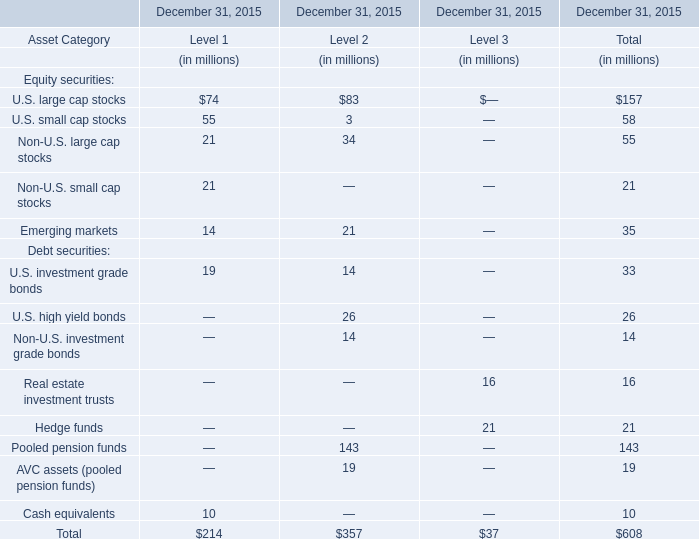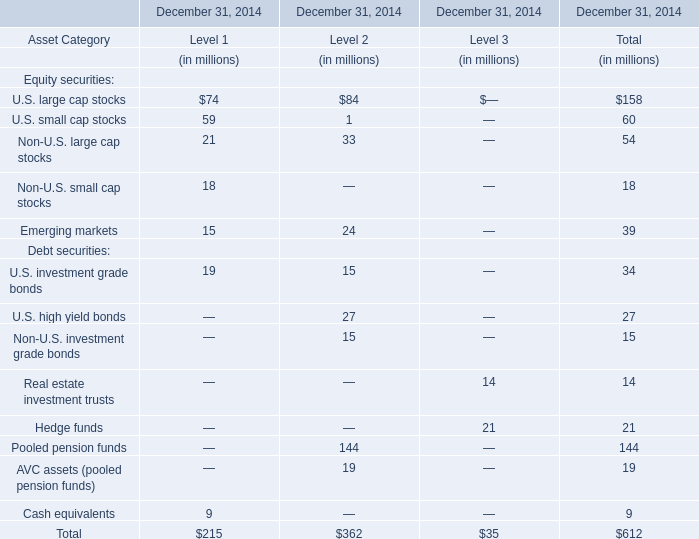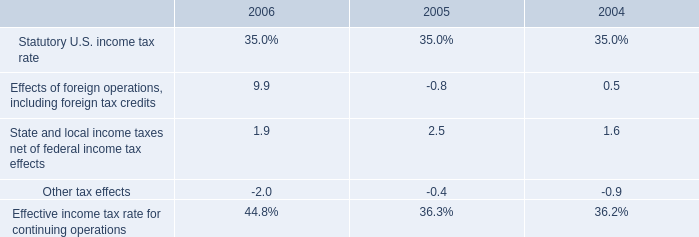What's the sum of the U.S. large cap stocks in the years where U.S. small cap stocks is positive? (in millions) 
Computations: (74 + 84)
Answer: 158.0. 